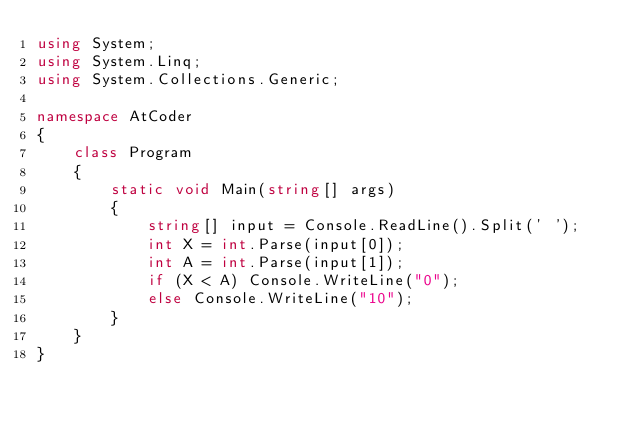Convert code to text. <code><loc_0><loc_0><loc_500><loc_500><_C#_>using System;
using System.Linq;
using System.Collections.Generic;

namespace AtCoder
{
    class Program
    {
        static void Main(string[] args)
        {
            string[] input = Console.ReadLine().Split(' ');
            int X = int.Parse(input[0]);
            int A = int.Parse(input[1]);
            if (X < A) Console.WriteLine("0");
            else Console.WriteLine("10");
        }
    }
}
</code> 